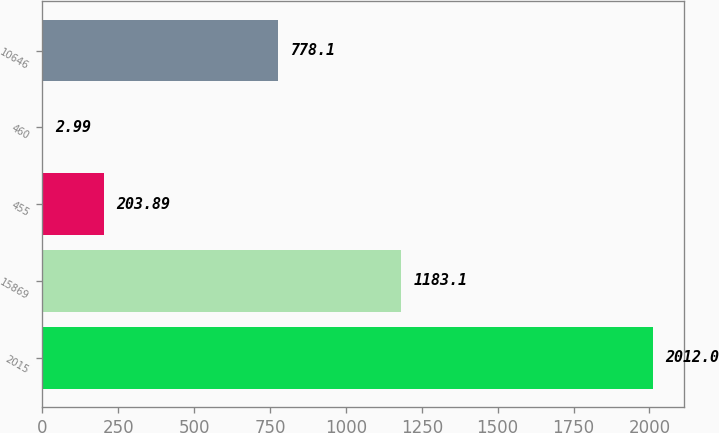<chart> <loc_0><loc_0><loc_500><loc_500><bar_chart><fcel>2015<fcel>15869<fcel>455<fcel>460<fcel>10646<nl><fcel>2012<fcel>1183.1<fcel>203.89<fcel>2.99<fcel>778.1<nl></chart> 